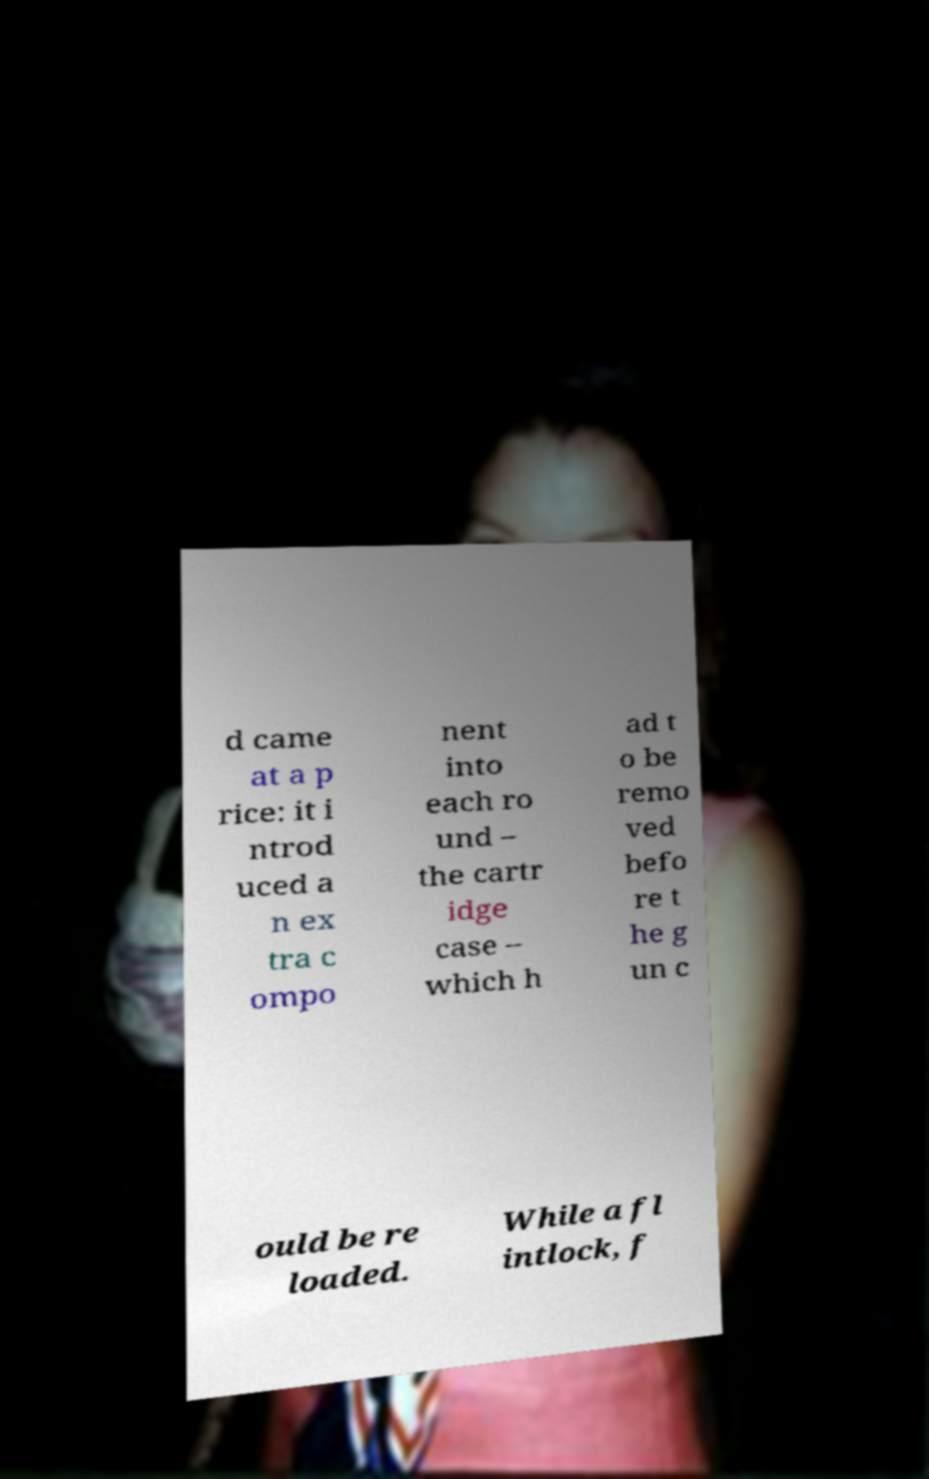What messages or text are displayed in this image? I need them in a readable, typed format. d came at a p rice: it i ntrod uced a n ex tra c ompo nent into each ro und – the cartr idge case – which h ad t o be remo ved befo re t he g un c ould be re loaded. While a fl intlock, f 